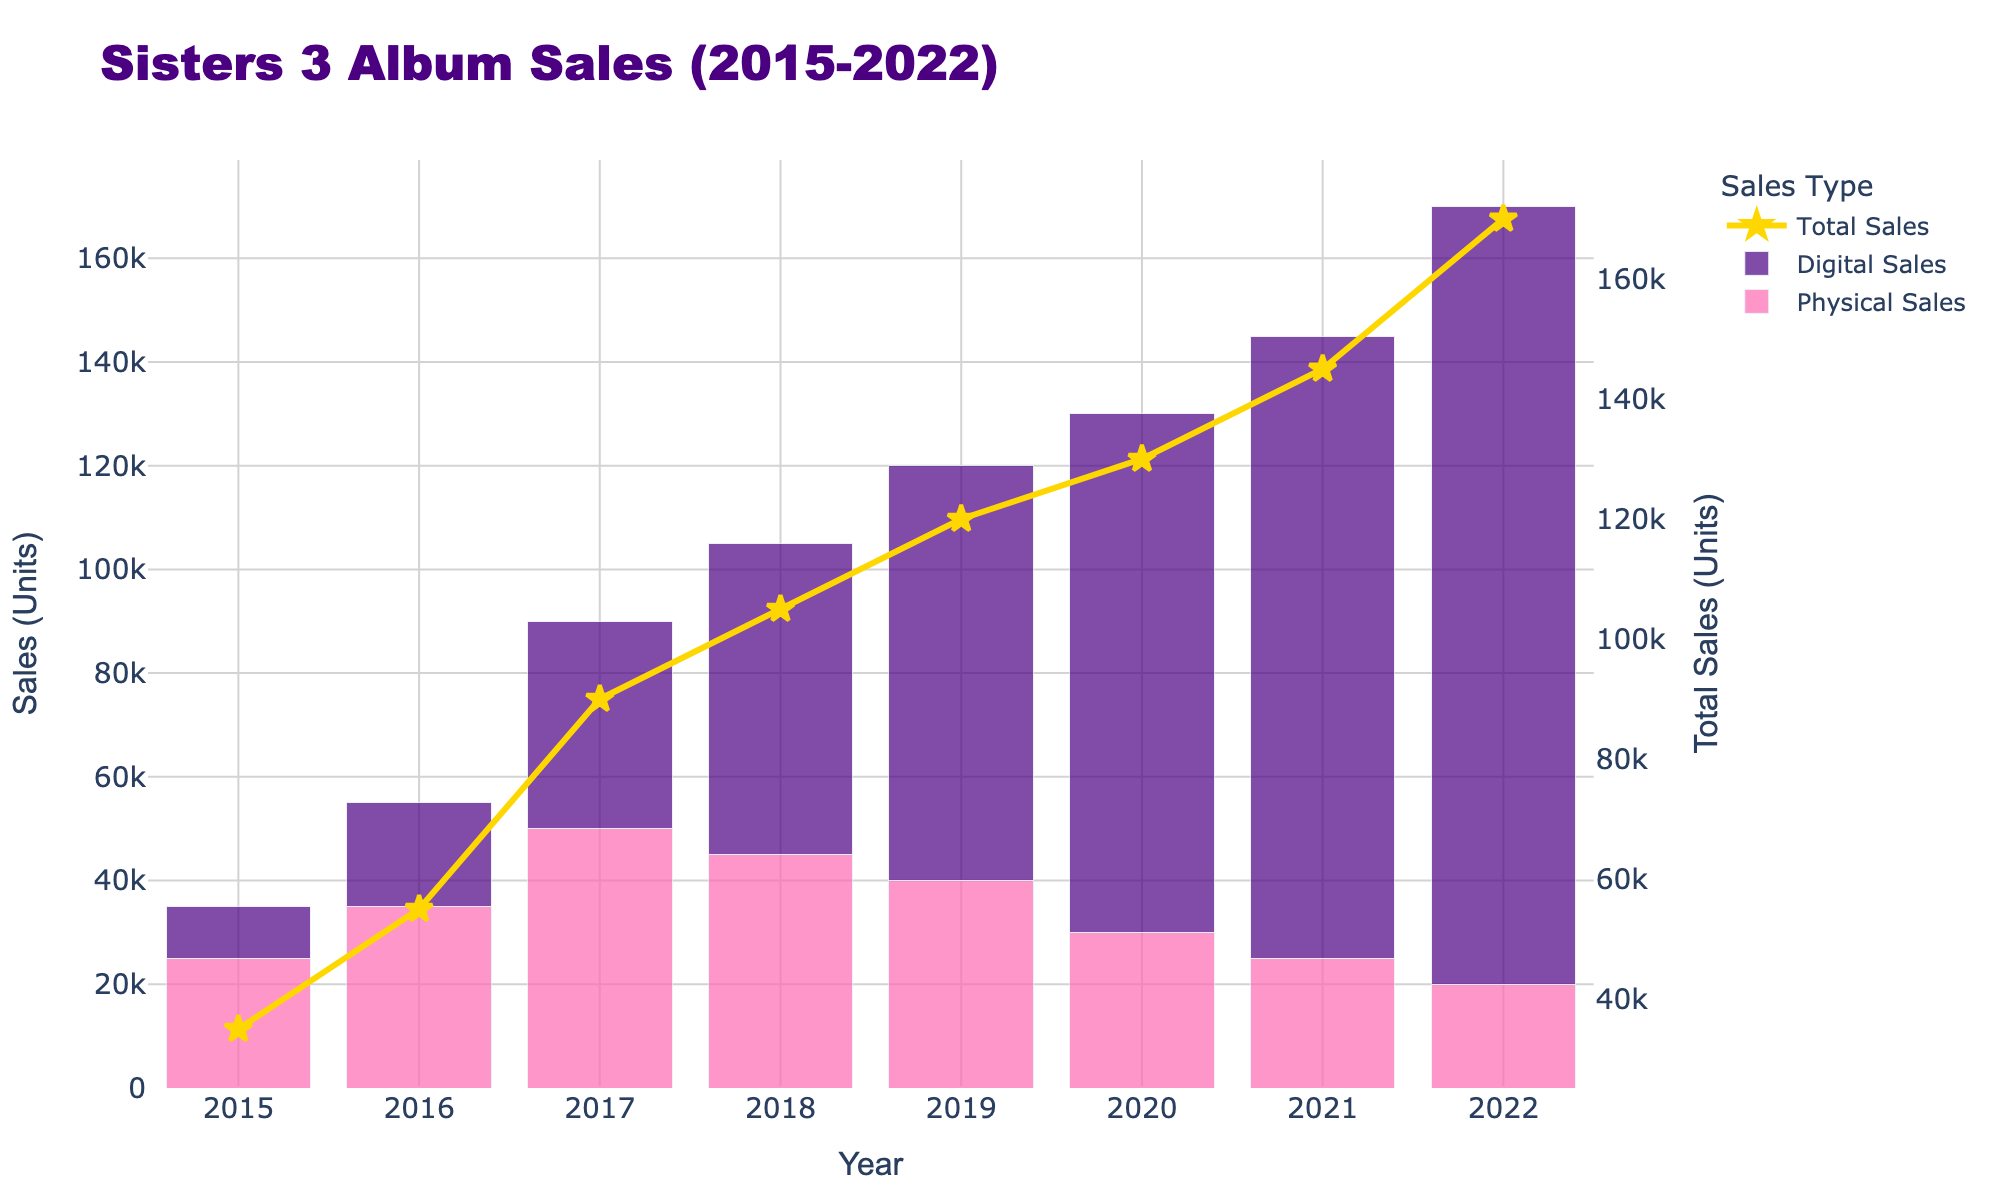What's the total combined sales in units for the year 2018? To get the total combined sales for 2018, sum the physical and digital sales for that year. From the chart, physical sales are 45,000 units and digital sales are 60,000 units. Adding these gives 45,000 + 60,000 = 105,000.
Answer: 105,000 In which year did digital sales first exceed physical sales? By comparing each bar set year by year, the year when the digital sales bar is higher than the physical sales bar for the first time is 2018.
Answer: 2018 How much did total sales increase or decrease from 2020 to 2021? From the figure, the total sales in 2020 is 130,000 units and in 2021 it is 145,000 units. To find the increase, subtract 130,000 from 145,000 which gives 145,000 - 130,000 = 15,000.
Answer: 15,000 increase What is the difference in digital sales between 2019 and 2022? The digital sales in 2019 is 80,000 units and in 2022 it is 150,000 units. Subtracting these gives 150,000 - 80,000 = 70,000.
Answer: 70,000 Which year had the highest total sales? The highest total sales can be found by observing where the combined line (total sales) peaks on the graph. The year with the highest total sales is 2022.
Answer: 2022 What is the ratio of physical to digital sales in 2017? In 2017, physical sales are 50,000 units and digital sales are 40,000 units. The ratio can be calculated as 50,000 / 40,000 = 5/4 or 1.25.
Answer: 1.25 By how much did physical sales decrease from 2019 to 2022? Physical sales in 2019 are 40,000 units and in 2022 they are 20,000 units. The decrease is found by subtracting 20,000 from 40,000 which gives 40,000 - 20,000 = 20,000.
Answer: 20,000 Which sales type had a greater increase from 2015 to 2021, physical or digital? To find which had a greater increase, calculate the increase for both sales types. For physical: 25,000 in 2015 to 25,000 in 2021 (no increase). For digital: 10,000 in 2015 to 120,000 in 2021, the increase is 120,000 - 10,000 = 110,000. Digital sales had a greater increase.
Answer: Digital What is the average physical sales per year over the period 2015-2022? To find the average, sum the physical sales from each year 2015-2022 and then divide by the number of years. The sum is 25,000 + 35,000 + 50,000 + 45,000 + 40,000 + 30,000 + 25,000 + 20,000 = 270,000. Dividing by 8 gives 270,000 / 8 = 33,750.
Answer: 33,750 